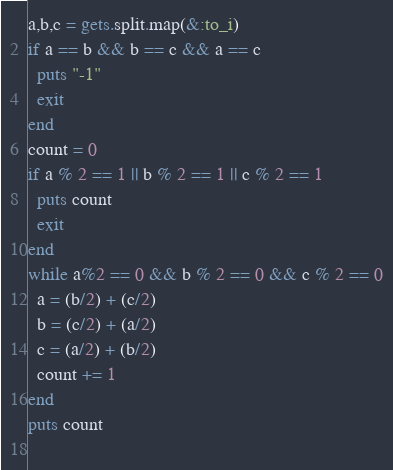Convert code to text. <code><loc_0><loc_0><loc_500><loc_500><_Ruby_>a,b,c = gets.split.map(&:to_i)
if a == b && b == c && a == c
  puts "-1"
  exit
end
count = 0
if a % 2 == 1 || b % 2 == 1 || c % 2 == 1
  puts count
  exit
end
while a%2 == 0 && b % 2 == 0 && c % 2 == 0
  a = (b/2) + (c/2)
  b = (c/2) + (a/2)
  c = (a/2) + (b/2)
  count += 1
end
puts count
 
</code> 